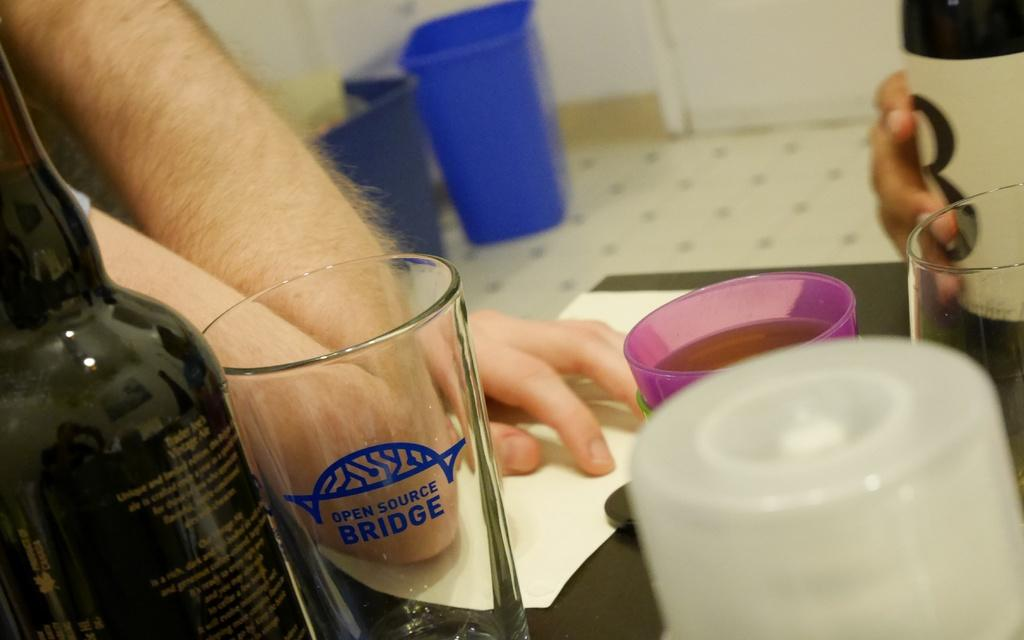<image>
Relay a brief, clear account of the picture shown. A person with their elbow on the table beside a glass with Open Source Bridge on it. 